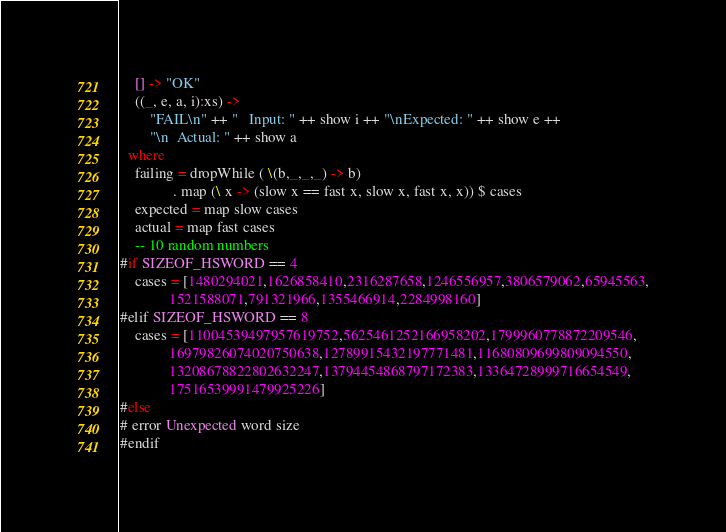Convert code to text. <code><loc_0><loc_0><loc_500><loc_500><_Haskell_>    [] -> "OK"
    ((_, e, a, i):xs) ->
        "FAIL\n" ++ "   Input: " ++ show i ++ "\nExpected: " ++ show e ++
        "\n  Actual: " ++ show a
  where
    failing = dropWhile ( \(b,_,_,_) -> b)
              . map (\ x -> (slow x == fast x, slow x, fast x, x)) $ cases
    expected = map slow cases
    actual = map fast cases
    -- 10 random numbers
#if SIZEOF_HSWORD == 4
    cases = [1480294021,1626858410,2316287658,1246556957,3806579062,65945563,
             1521588071,791321966,1355466914,2284998160]
#elif SIZEOF_HSWORD == 8
    cases = [11004539497957619752,5625461252166958202,1799960778872209546,
             16979826074020750638,12789915432197771481,11680809699809094550,
             13208678822802632247,13794454868797172383,13364728999716654549,
             17516539991479925226]
#else
# error Unexpected word size
#endif
</code> 